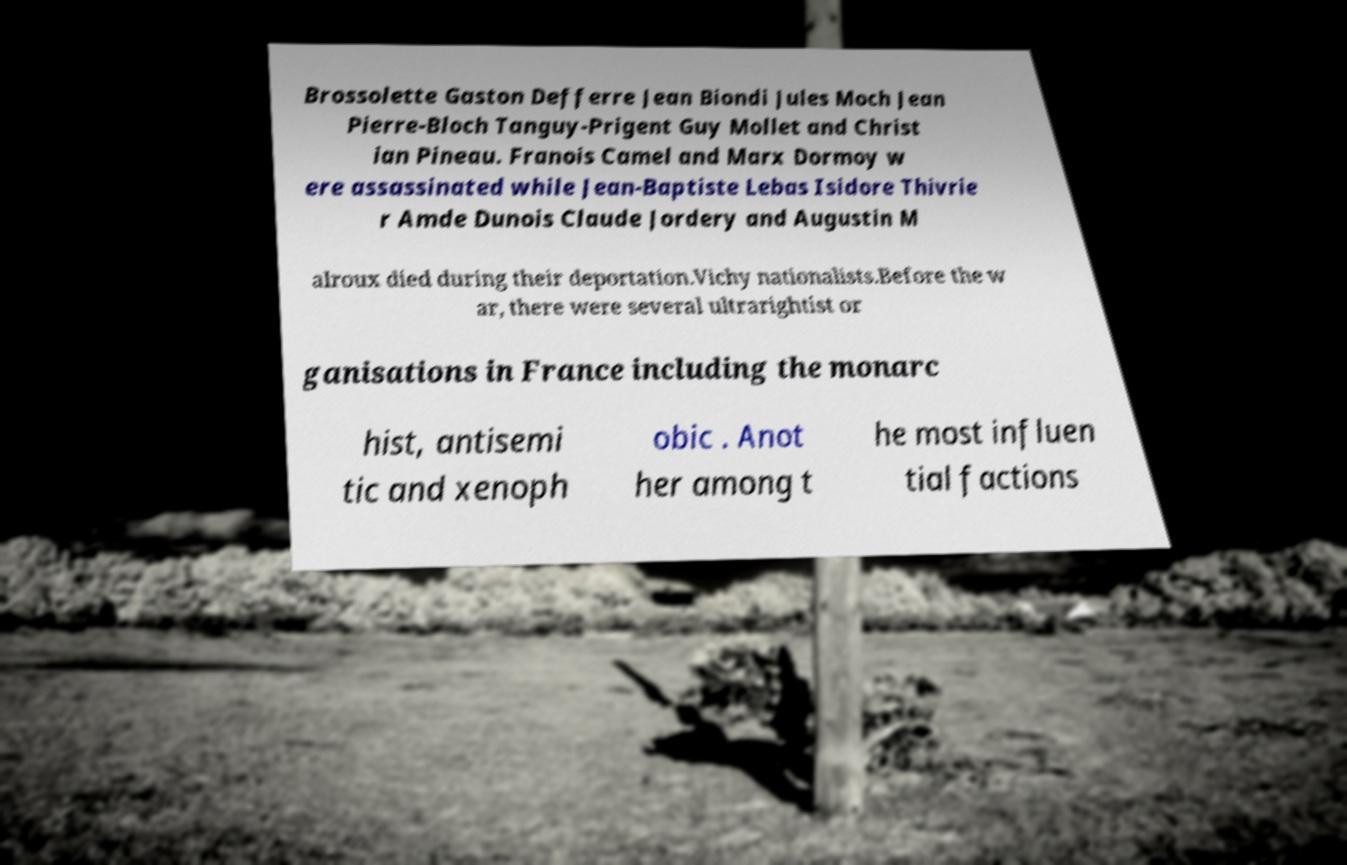I need the written content from this picture converted into text. Can you do that? Brossolette Gaston Defferre Jean Biondi Jules Moch Jean Pierre-Bloch Tanguy-Prigent Guy Mollet and Christ ian Pineau. Franois Camel and Marx Dormoy w ere assassinated while Jean-Baptiste Lebas Isidore Thivrie r Amde Dunois Claude Jordery and Augustin M alroux died during their deportation.Vichy nationalists.Before the w ar, there were several ultrarightist or ganisations in France including the monarc hist, antisemi tic and xenoph obic . Anot her among t he most influen tial factions 